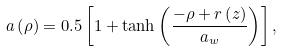<formula> <loc_0><loc_0><loc_500><loc_500>a \left ( \rho \right ) = 0 . 5 \left [ 1 + \tanh \left ( \frac { - \rho + r \left ( z \right ) } { a _ { w } } \right ) \right ] ,</formula> 